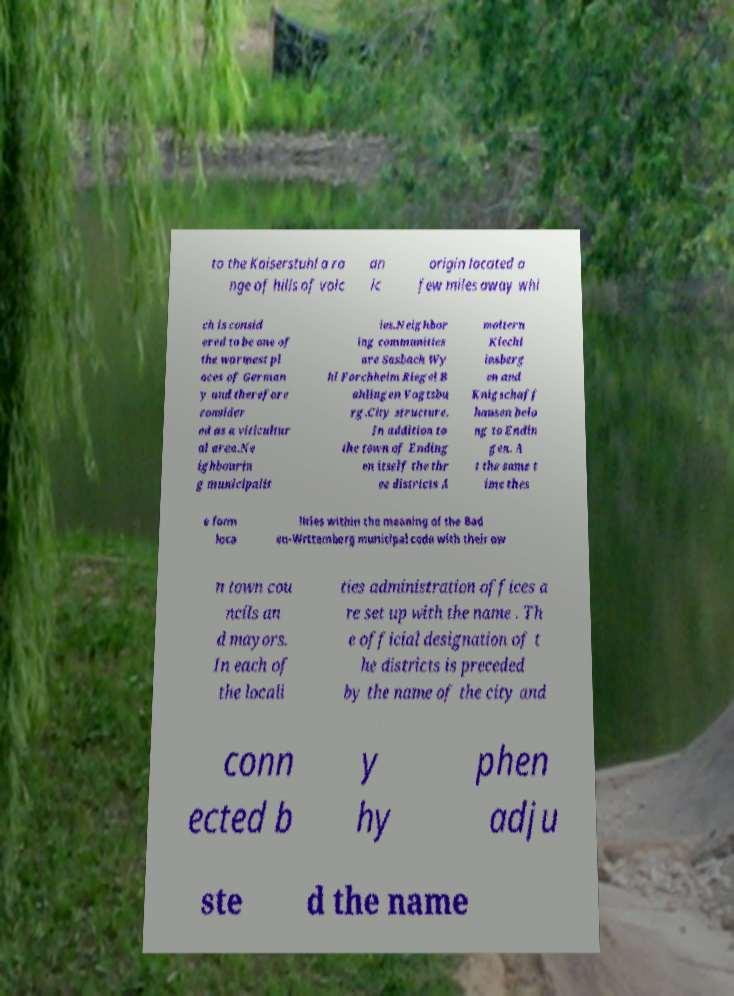Please read and relay the text visible in this image. What does it say? to the Kaiserstuhl a ra nge of hills of volc an ic origin located a few miles away whi ch is consid ered to be one of the warmest pl aces of German y and therefore consider ed as a viticultur al area.Ne ighbourin g municipalit ies.Neighbor ing communities are Sasbach Wy hl Forchheim Riegel B ahlingen Vogtsbu rg.City structure. In addition to the town of Ending en itself the thr ee districts A moltern Kiechl insberg en and Knigschaff hausen belo ng to Endin gen. A t the same t ime thes e form loca lities within the meaning of the Bad en-Wrttemberg municipal code with their ow n town cou ncils an d mayors. In each of the locali ties administration offices a re set up with the name . Th e official designation of t he districts is preceded by the name of the city and conn ected b y hy phen adju ste d the name 